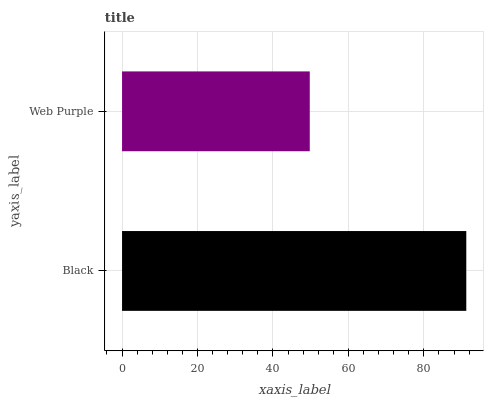Is Web Purple the minimum?
Answer yes or no. Yes. Is Black the maximum?
Answer yes or no. Yes. Is Web Purple the maximum?
Answer yes or no. No. Is Black greater than Web Purple?
Answer yes or no. Yes. Is Web Purple less than Black?
Answer yes or no. Yes. Is Web Purple greater than Black?
Answer yes or no. No. Is Black less than Web Purple?
Answer yes or no. No. Is Black the high median?
Answer yes or no. Yes. Is Web Purple the low median?
Answer yes or no. Yes. Is Web Purple the high median?
Answer yes or no. No. Is Black the low median?
Answer yes or no. No. 